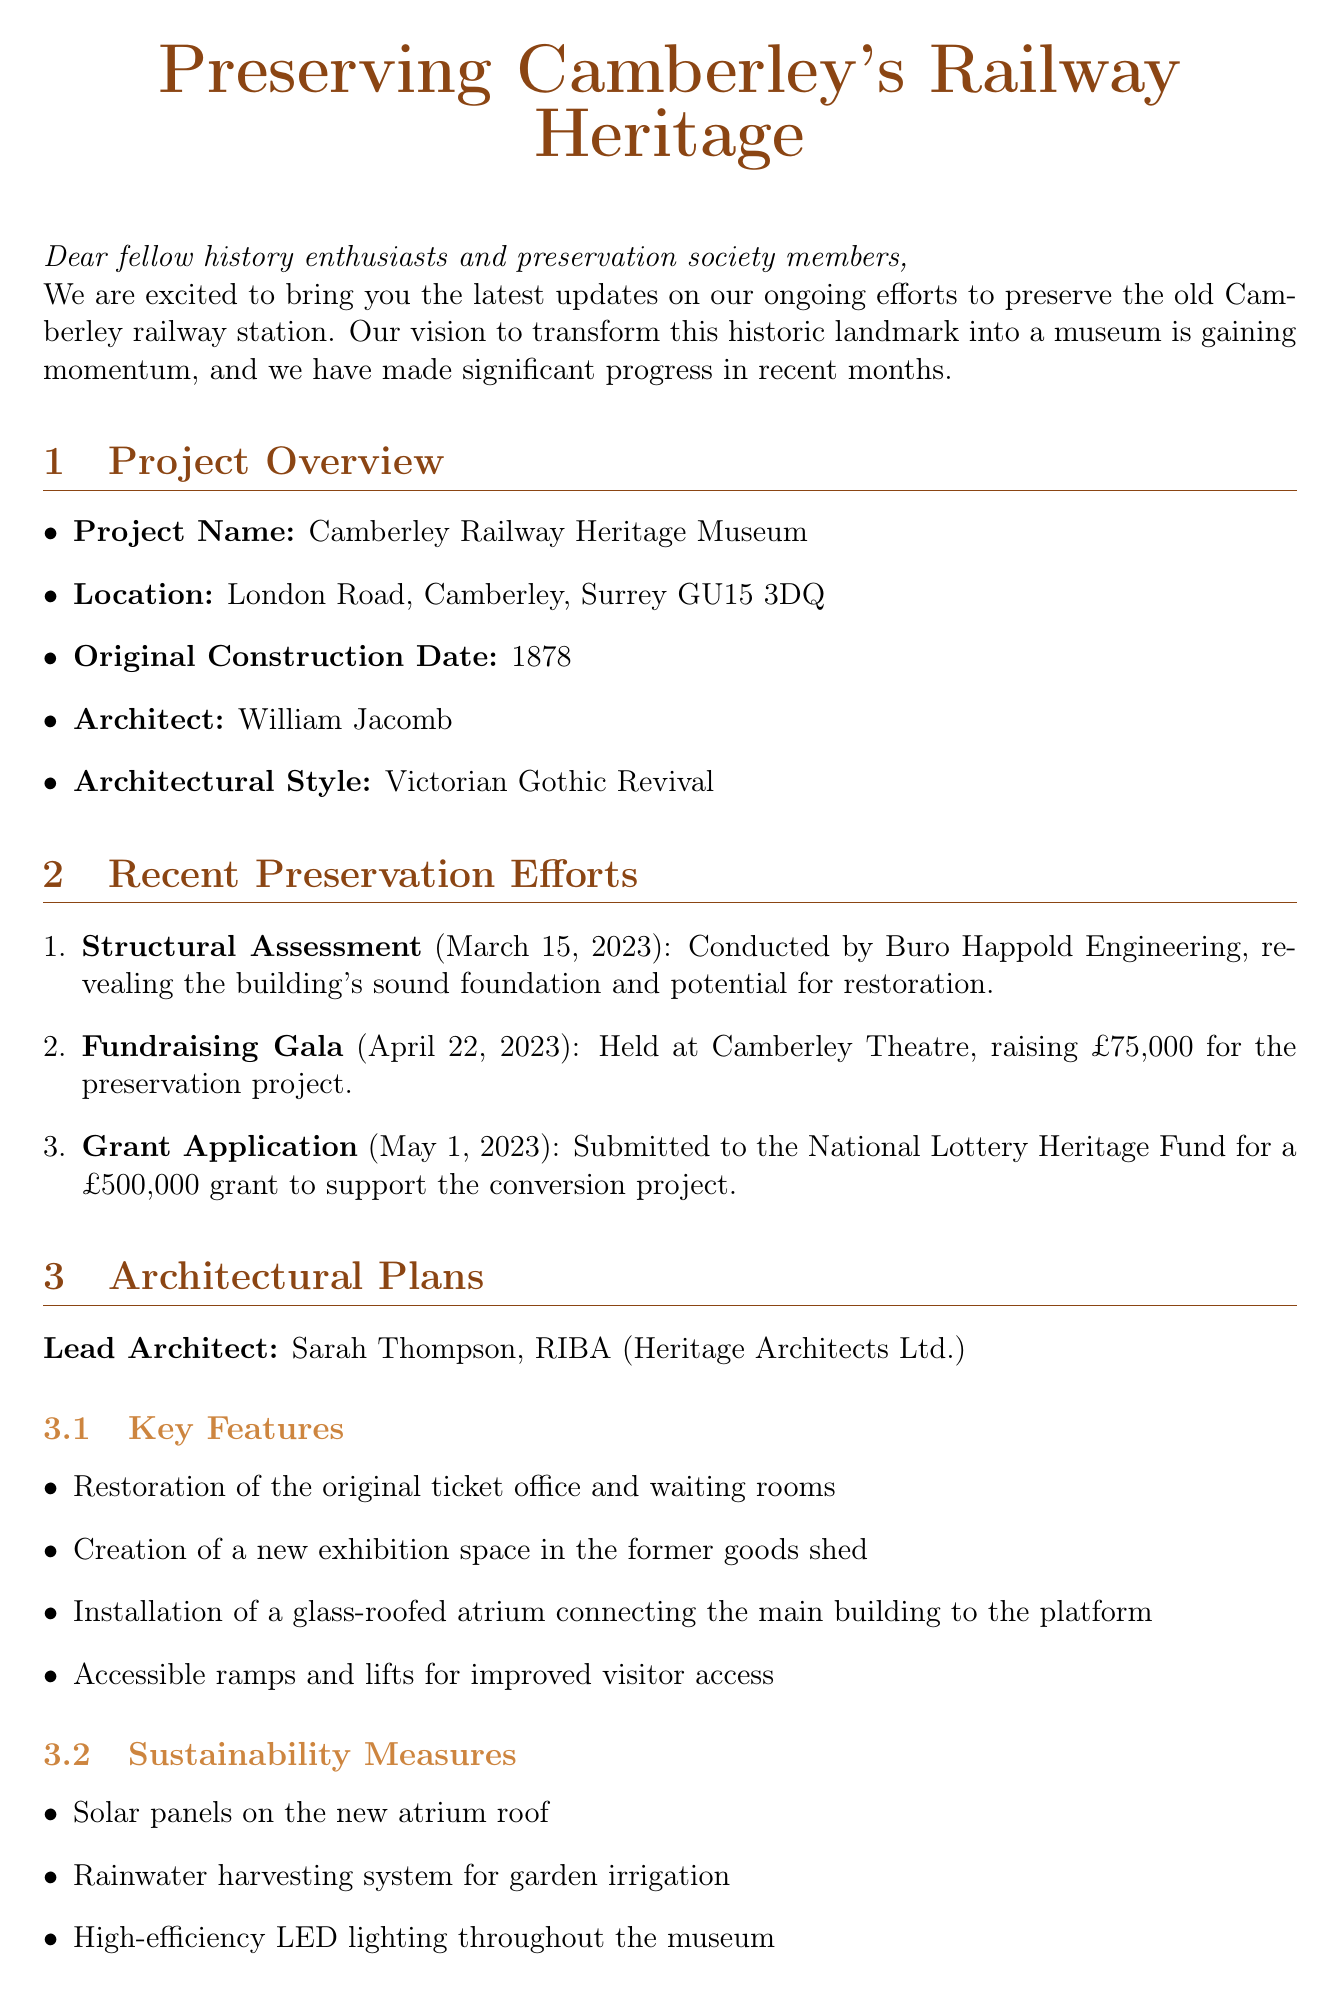What is the project name? The project name is explicitly mentioned in the document.
Answer: Camberley Railway Heritage Museum Who conducted the structural assessment? The document specifies who performed the structural assessment of the station.
Answer: Buro Happold Engineering When was the grant application submitted? The submission date of the grant application is clearly stated in the document.
Answer: May 1, 2023 What is one of the key features of the architectural plans? The document lists key features, allowing for the identification of any specific item.
Answer: Restoration of the original ticket office and waiting rooms How much was raised at the fundraising gala? The total raised during the fundraising event is provided in the document.
Answer: £75,000 What will visitors experience in the Interactive Signal Box exhibit? The document describes the experience associated with the Interactive Signal Box exhibit.
Answer: The role of a signalman What is the expected decision time on the grant application? The document indicates when the decision on the grant application is projected.
Answer: August 2023 What sustainability measure is included for the museum? The document lists sustainability measures, revealing various eco-friendly initiatives.
Answer: Solar panels on the new atrium roof What type of programs will be offered for adults? The document mentions educational programs aimed at adult learners.
Answer: Adult learning courses on heritage preservation techniques 